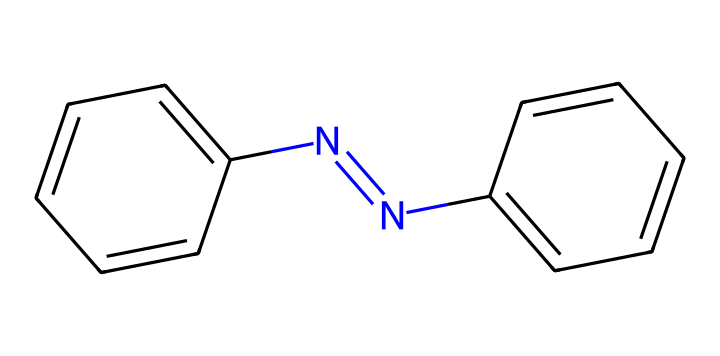What is the molecular formula of azobenzene? The chemical structure consists of two benzene rings connected by a nitrogen-nitrogen double bond (N=N). Each benzene ring contributes six carbons (C) and five hydrogens (H), leading to a total of 12 carbons, 10 hydrogens, and two nitrogens. Thus, the molecular formula is C12H10N2.
Answer: C12H10N2 How many double bonds are present in azobenzene? The structure has one double bond between the nitrogen atoms (N=N) and also includes the double bonds within each of the benzene rings. Since each benzene contributes three double bonds, there are a total of 1 + 6 = 7 double bonds. However, if only counting the unique bond connecting the rings, the answer is 1 distinct double bond.
Answer: 1 What type of isomerism can azobenzene exhibit? Azobenzene can exist in two geometric forms: the cis and trans configurations, depending on the orientation of the substituents around the nitrogen-nitrogen double bond. This isomerism arises because rotation around the N=N bond is restricted. Hence, the answer refers to this characteristic.
Answer: geometric isomerism What role do the aromatic rings play in azobenzene? The aromatic rings provide stability and contribute to the photophysical properties of azobenzene. They facilitate π conjugation and resonance, which are essential for its application as a photoswitchable molecule. This stability and electronic configuration enable azobenzene to absorb light and change conformation.
Answer: stability What is the primary application of azobenzene in smart materials? Azobenzene's ability to switch between its cis and trans forms upon exposure to light makes it valuable in smart materials, specifically in the development of light-responsive polymers and devices. This unique characteristic allows for dynamic control of material properties in environments where light can be applied.
Answer: light-responsive polymers 